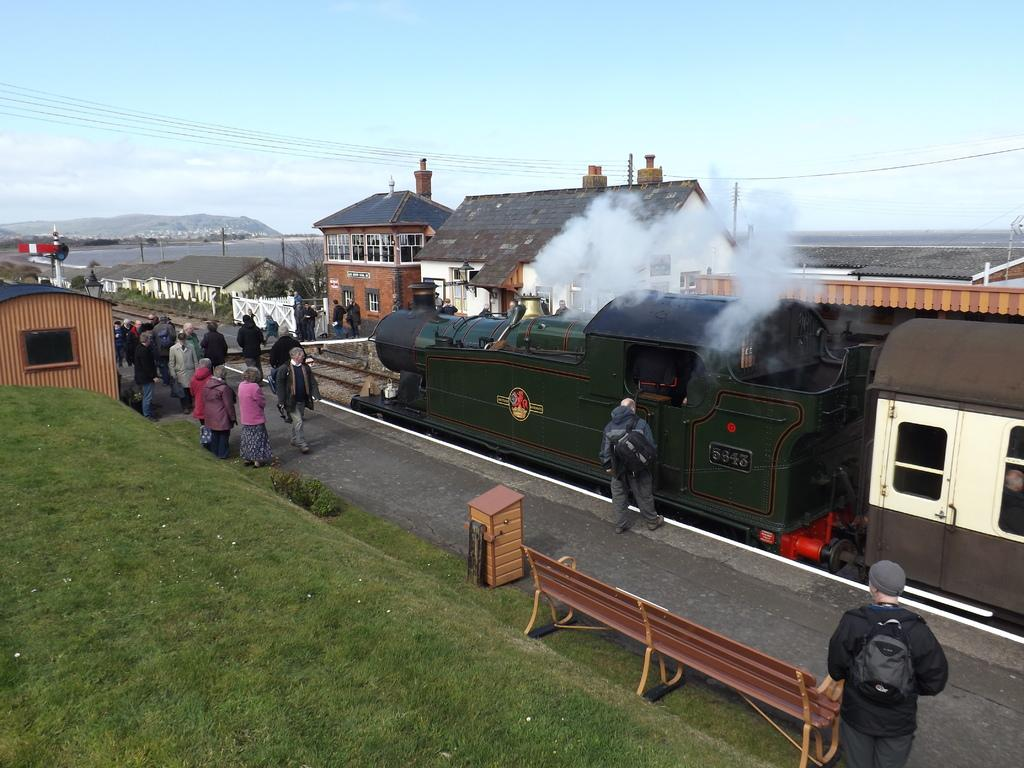What is the main subject of the image? The main subject of the image is a train. Where are people located in the image? People are standing on a platform in the image. What can be seen in the background of the image? There are buildings and clouds visible in the background of the image. What is visible in the sky in the image? The sky is visible in the background of the image. What type of property is being sold in the image? There is no property being sold in the image; it features a train and a platform with people. Can you tell me how many guns are visible in the image? There are no guns present in the image. 